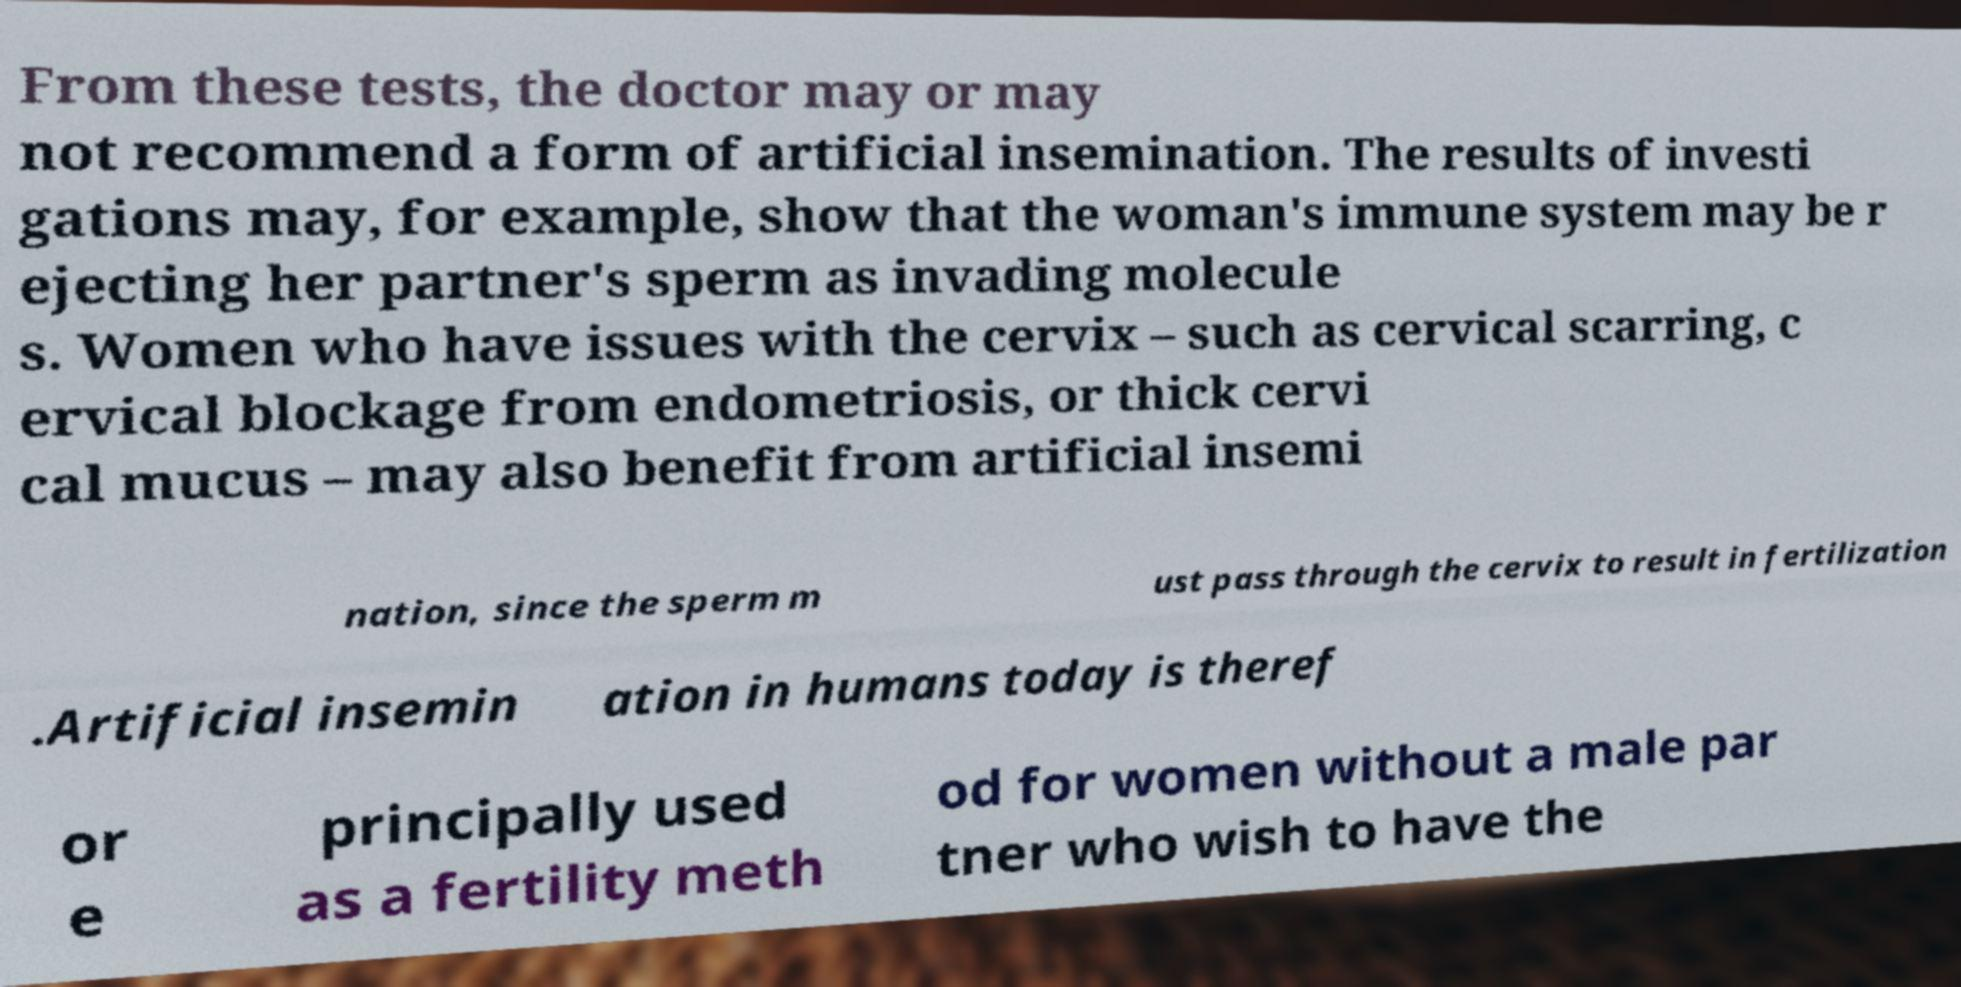Can you read and provide the text displayed in the image?This photo seems to have some interesting text. Can you extract and type it out for me? From these tests, the doctor may or may not recommend a form of artificial insemination. The results of investi gations may, for example, show that the woman's immune system may be r ejecting her partner's sperm as invading molecule s. Women who have issues with the cervix – such as cervical scarring, c ervical blockage from endometriosis, or thick cervi cal mucus – may also benefit from artificial insemi nation, since the sperm m ust pass through the cervix to result in fertilization .Artificial insemin ation in humans today is theref or e principally used as a fertility meth od for women without a male par tner who wish to have the 